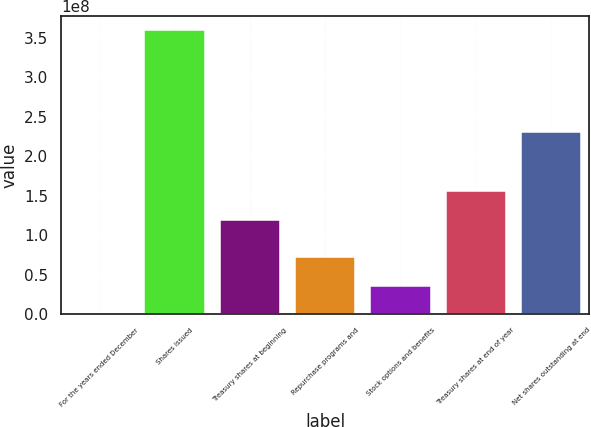<chart> <loc_0><loc_0><loc_500><loc_500><bar_chart><fcel>For the years ended December<fcel>Shares issued<fcel>Treasury shares at beginning<fcel>Repurchase programs and<fcel>Stock options and benefits<fcel>Treasury shares at end of year<fcel>Net shares outstanding at end<nl><fcel>2006<fcel>3.59902e+08<fcel>1.19378e+08<fcel>7.1982e+07<fcel>3.5992e+07<fcel>1.55368e+08<fcel>2.30264e+08<nl></chart> 